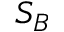Convert formula to latex. <formula><loc_0><loc_0><loc_500><loc_500>S _ { B }</formula> 